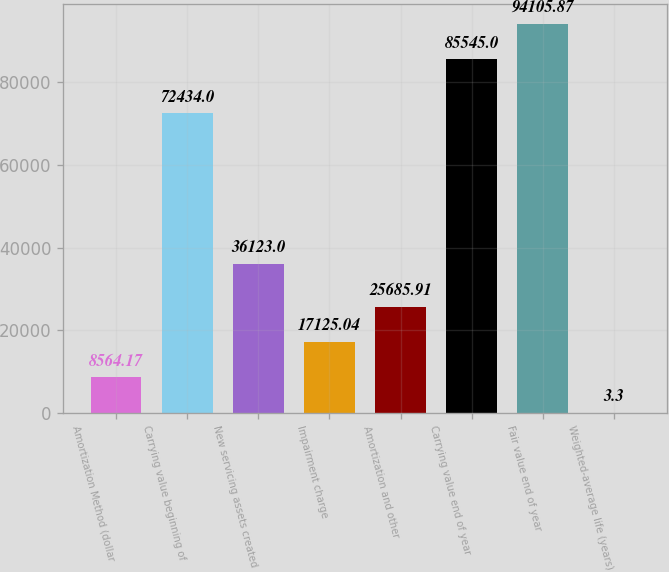<chart> <loc_0><loc_0><loc_500><loc_500><bar_chart><fcel>Amortization Method (dollar<fcel>Carrying value beginning of<fcel>New servicing assets created<fcel>Impairment charge<fcel>Amortization and other<fcel>Carrying value end of year<fcel>Fair value end of year<fcel>Weighted-average life (years)<nl><fcel>8564.17<fcel>72434<fcel>36123<fcel>17125<fcel>25685.9<fcel>85545<fcel>94105.9<fcel>3.3<nl></chart> 